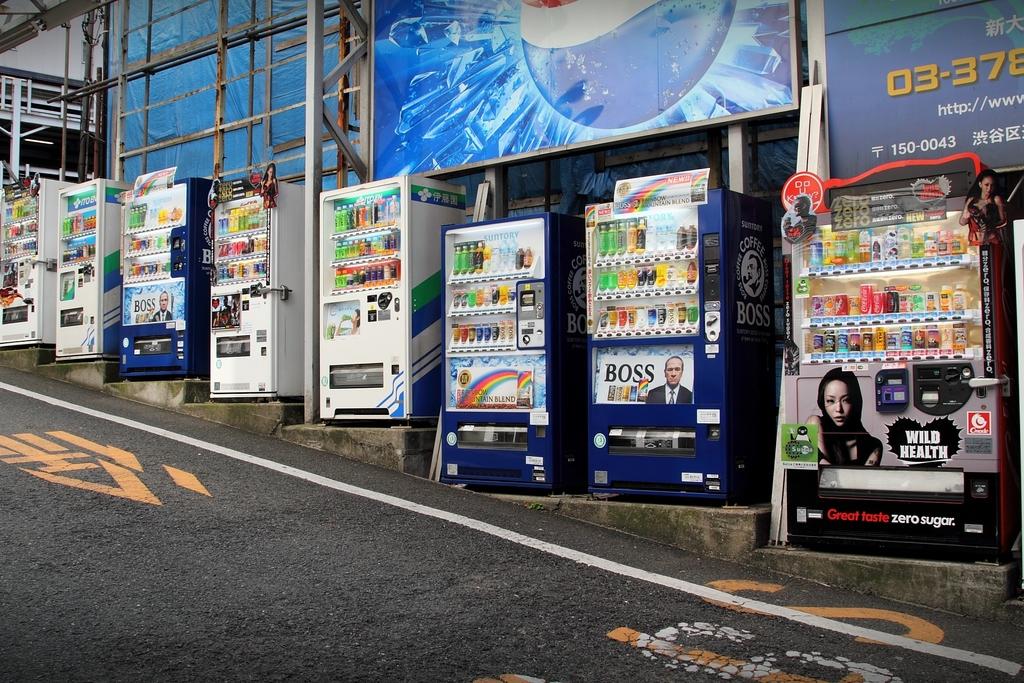What does the machine say on the far right at the bottom in red?
Provide a succinct answer. Great taste. 